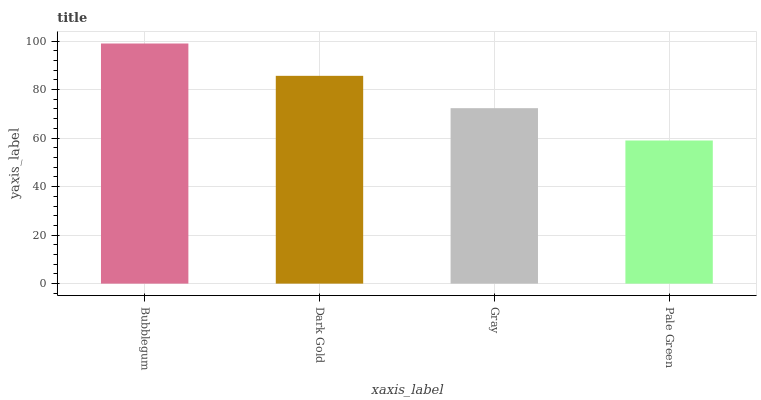Is Pale Green the minimum?
Answer yes or no. Yes. Is Bubblegum the maximum?
Answer yes or no. Yes. Is Dark Gold the minimum?
Answer yes or no. No. Is Dark Gold the maximum?
Answer yes or no. No. Is Bubblegum greater than Dark Gold?
Answer yes or no. Yes. Is Dark Gold less than Bubblegum?
Answer yes or no. Yes. Is Dark Gold greater than Bubblegum?
Answer yes or no. No. Is Bubblegum less than Dark Gold?
Answer yes or no. No. Is Dark Gold the high median?
Answer yes or no. Yes. Is Gray the low median?
Answer yes or no. Yes. Is Pale Green the high median?
Answer yes or no. No. Is Pale Green the low median?
Answer yes or no. No. 